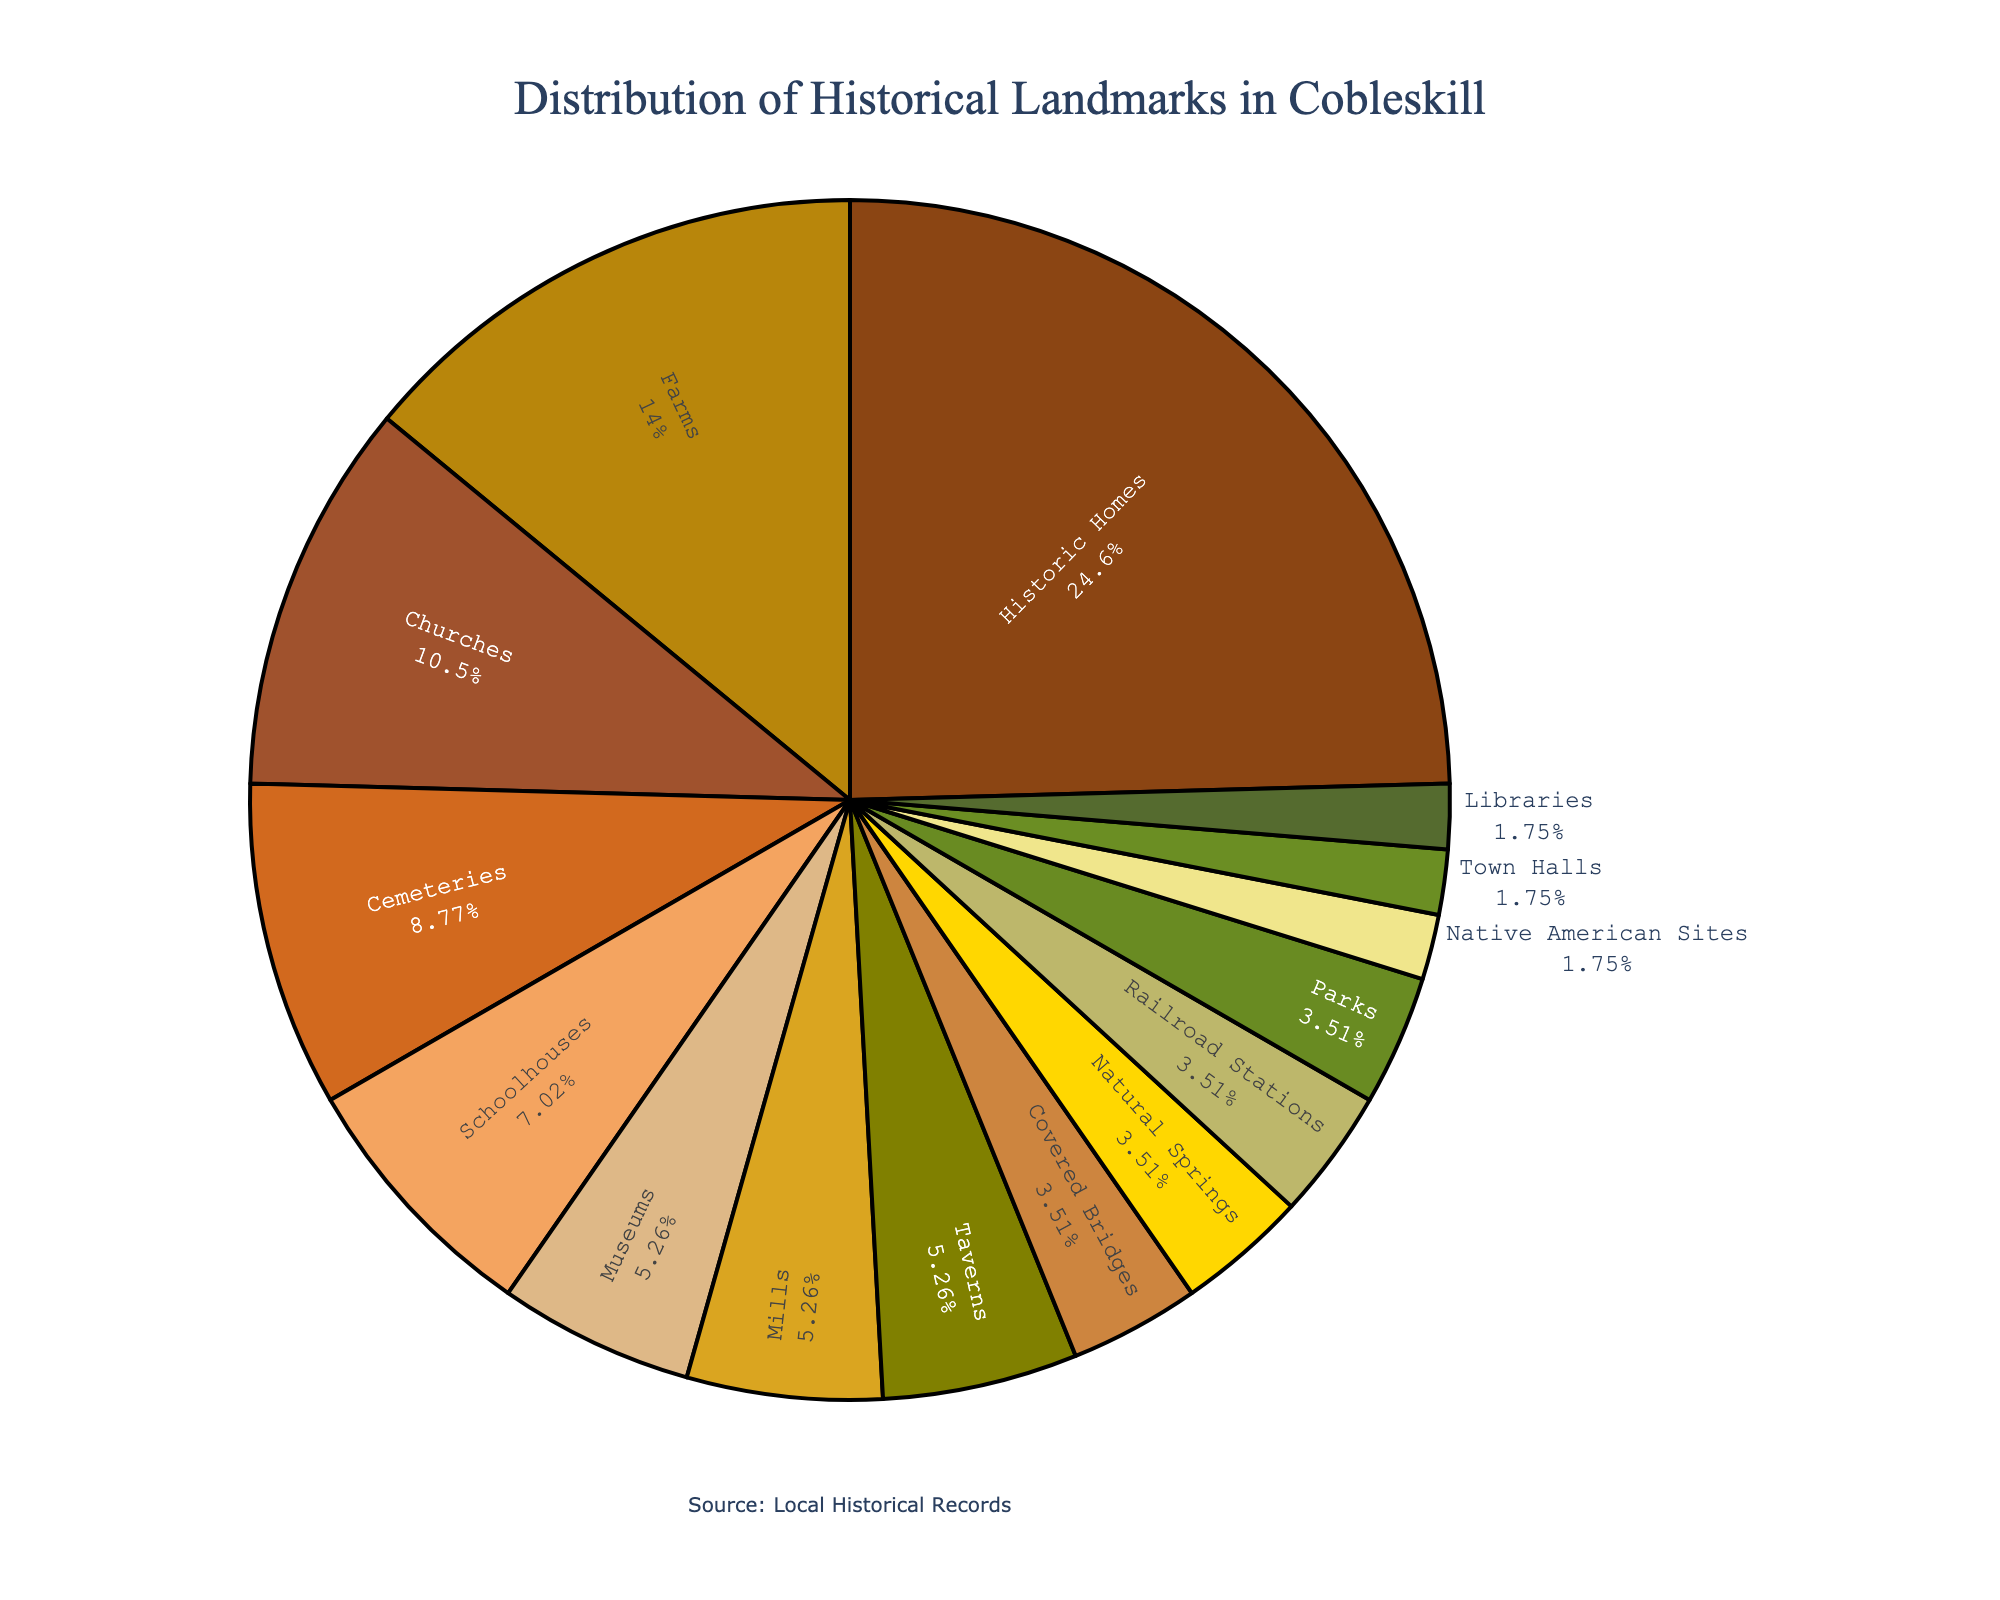How many more historic homes are there compared to churches? The figure shows 14 historic homes and 6 churches. Subtracting the number of churches from historic homes gives 14 - 6 = 8.
Answer: 8 Which type of historical landmark has the smallest presence in Cobleskill? The figure indicates only 1 landmark each for Native American Sites, Town Halls, and Libraries.
Answer: Native American Sites, Town Halls, Libraries What percent of the total landmarks are cemeteries? The figure shows there are 5 cemeteries out of a total of 54 landmarks. The percentage is calculated by (5/54) * 100 = 9.26%.
Answer: 9.26% Are there more museums or taverns in Cobleskill? The figure shows there are 3 museums and 3 taverns, so they are equal in number.
Answer: Equal What is the combined total of mills and covered bridges? The figure shows there are 3 mills and 2 covered bridges. Adding these together gives 3 + 2 = 5.
Answer: 5 How does the number of farms compare to the number of cemeteries? The figure indicates there are 8 farms and 5 cemeteries. 8 is greater than 5.
Answer: More If you combine historic homes, schoolhouses, and taverns, what proportion of the total landmarks do they represent? There are 14 historic homes, 4 schoolhouses, and 3 taverns, making a total of 21. The overall total number of landmarks is 54. The proportion is calculated by (21/54) * 100 ≈ 38.89%.
Answer: 38.89% What is the combined percentage of natural springs and railroad stations? The figure shows 2 natural springs and 2 railroad stations. Combined, this makes 4 landmarks out of 54. The percentage is (4/54) * 100 ≈ 7.41%.
Answer: 7.41% Which landmark type has the highest frequency, and what is its count? The figure shows that historic homes have the highest frequency with 14 landmarks.
Answer: Historic Homes, 14 